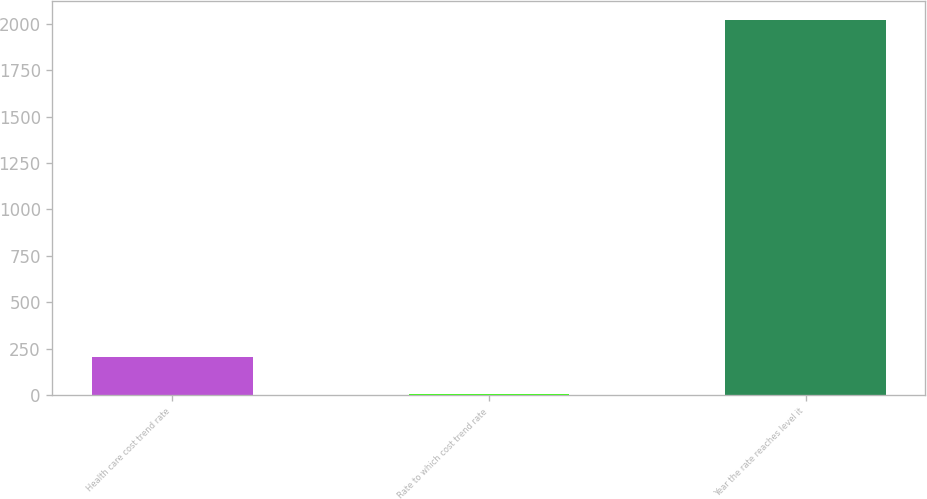Convert chart. <chart><loc_0><loc_0><loc_500><loc_500><bar_chart><fcel>Health care cost trend rate<fcel>Rate to which cost trend rate<fcel>Year the rate reaches level it<nl><fcel>206.5<fcel>5<fcel>2020<nl></chart> 